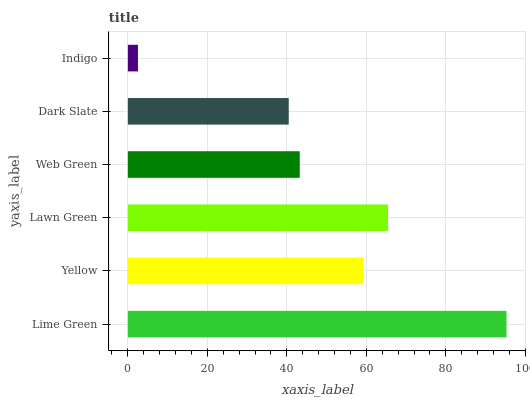Is Indigo the minimum?
Answer yes or no. Yes. Is Lime Green the maximum?
Answer yes or no. Yes. Is Yellow the minimum?
Answer yes or no. No. Is Yellow the maximum?
Answer yes or no. No. Is Lime Green greater than Yellow?
Answer yes or no. Yes. Is Yellow less than Lime Green?
Answer yes or no. Yes. Is Yellow greater than Lime Green?
Answer yes or no. No. Is Lime Green less than Yellow?
Answer yes or no. No. Is Yellow the high median?
Answer yes or no. Yes. Is Web Green the low median?
Answer yes or no. Yes. Is Web Green the high median?
Answer yes or no. No. Is Dark Slate the low median?
Answer yes or no. No. 